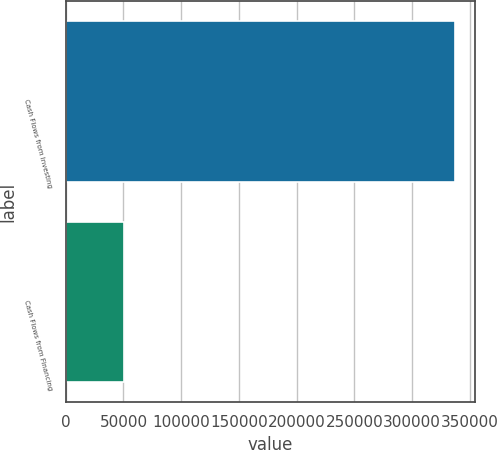<chart> <loc_0><loc_0><loc_500><loc_500><bar_chart><fcel>Cash Flows from Investing<fcel>Cash Flows from Financing<nl><fcel>337355<fcel>50391<nl></chart> 